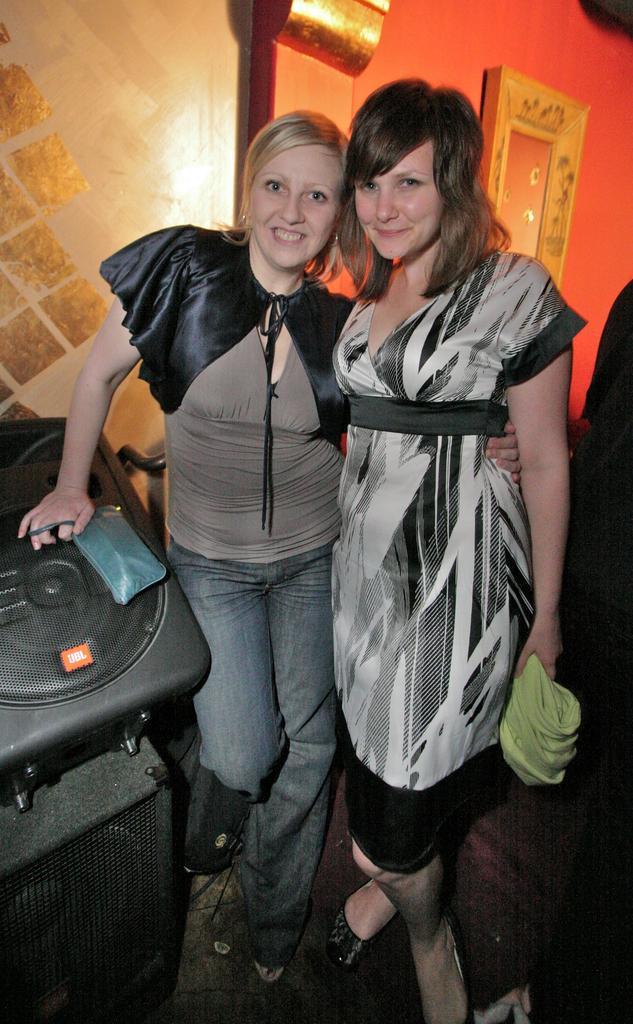Can you describe this image briefly? In the middle of the image two women are standing and smiling and holding something. Behind them there is wall. 